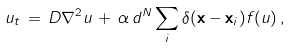Convert formula to latex. <formula><loc_0><loc_0><loc_500><loc_500>u _ { t } \, = \, D \nabla ^ { 2 } u \, + \, \alpha \, d ^ { N } \sum _ { i } \delta ( { \mathbf x } - { \mathbf x } _ { i } ) f ( u ) \, ,</formula> 